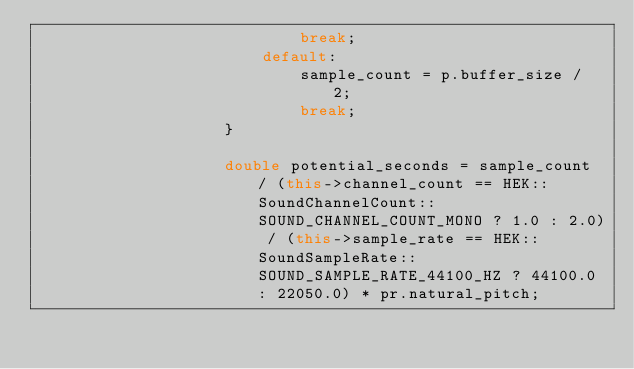Convert code to text. <code><loc_0><loc_0><loc_500><loc_500><_C++_>                            break;
                        default:
                            sample_count = p.buffer_size / 2;
                            break;
                    }
                    
                    double potential_seconds = sample_count / (this->channel_count == HEK::SoundChannelCount::SOUND_CHANNEL_COUNT_MONO ? 1.0 : 2.0) / (this->sample_rate == HEK::SoundSampleRate::SOUND_SAMPLE_RATE_44100_HZ ? 44100.0 : 22050.0) * pr.natural_pitch;
                    </code> 